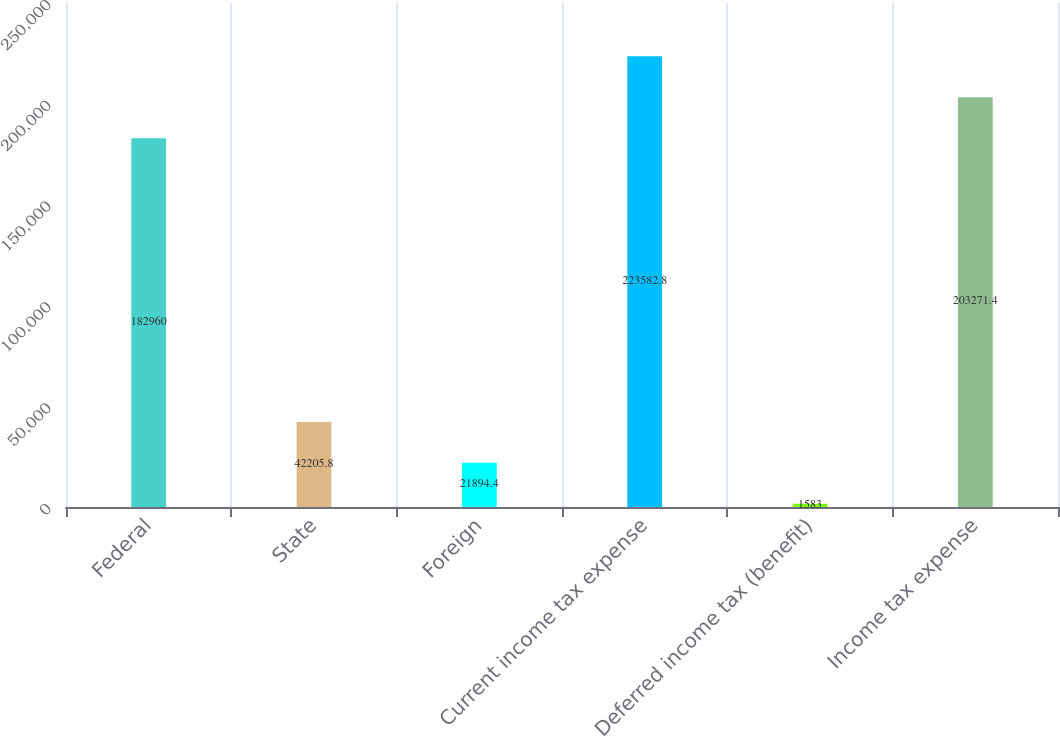Convert chart. <chart><loc_0><loc_0><loc_500><loc_500><bar_chart><fcel>Federal<fcel>State<fcel>Foreign<fcel>Current income tax expense<fcel>Deferred income tax (benefit)<fcel>Income tax expense<nl><fcel>182960<fcel>42205.8<fcel>21894.4<fcel>223583<fcel>1583<fcel>203271<nl></chart> 